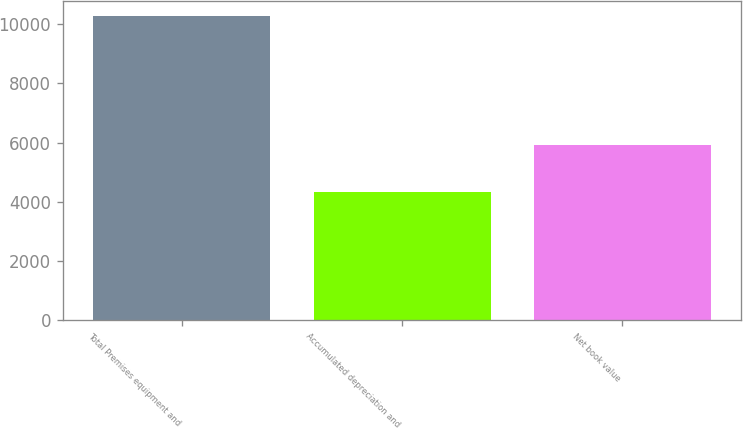<chart> <loc_0><loc_0><loc_500><loc_500><bar_chart><fcel>Total Premises equipment and<fcel>Accumulated depreciation and<fcel>Net book value<nl><fcel>10257<fcel>4349<fcel>5908<nl></chart> 